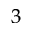Convert formula to latex. <formula><loc_0><loc_0><loc_500><loc_500>^ { 3 }</formula> 